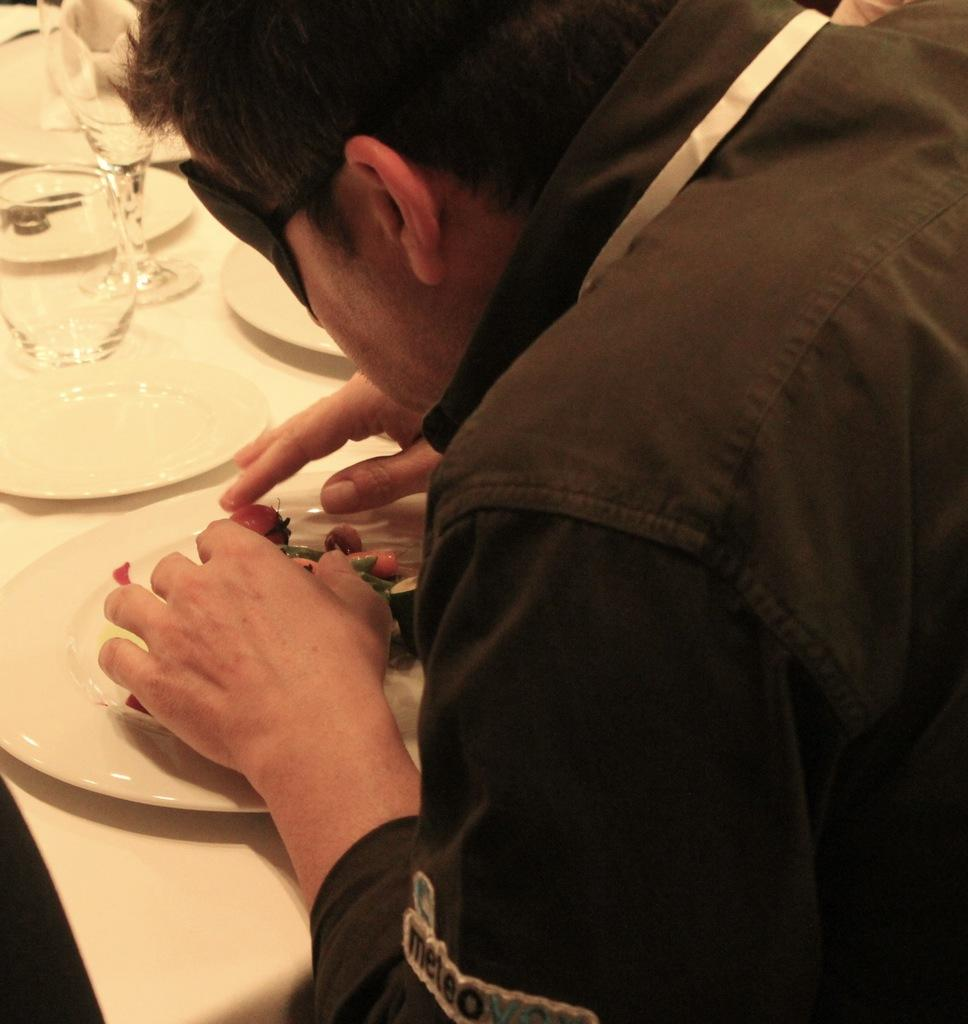What objects are present in the image that are typically used for serving food? There are plates in the image. What objects are present in the image that are typically used for drinking wine? There are wine glasses in the image. Can you describe the person in the image? Unfortunately, the provided facts do not mention any details about the person in the image. What type of chair is the house sitting on in the image? There is no house or chair present in the image. 